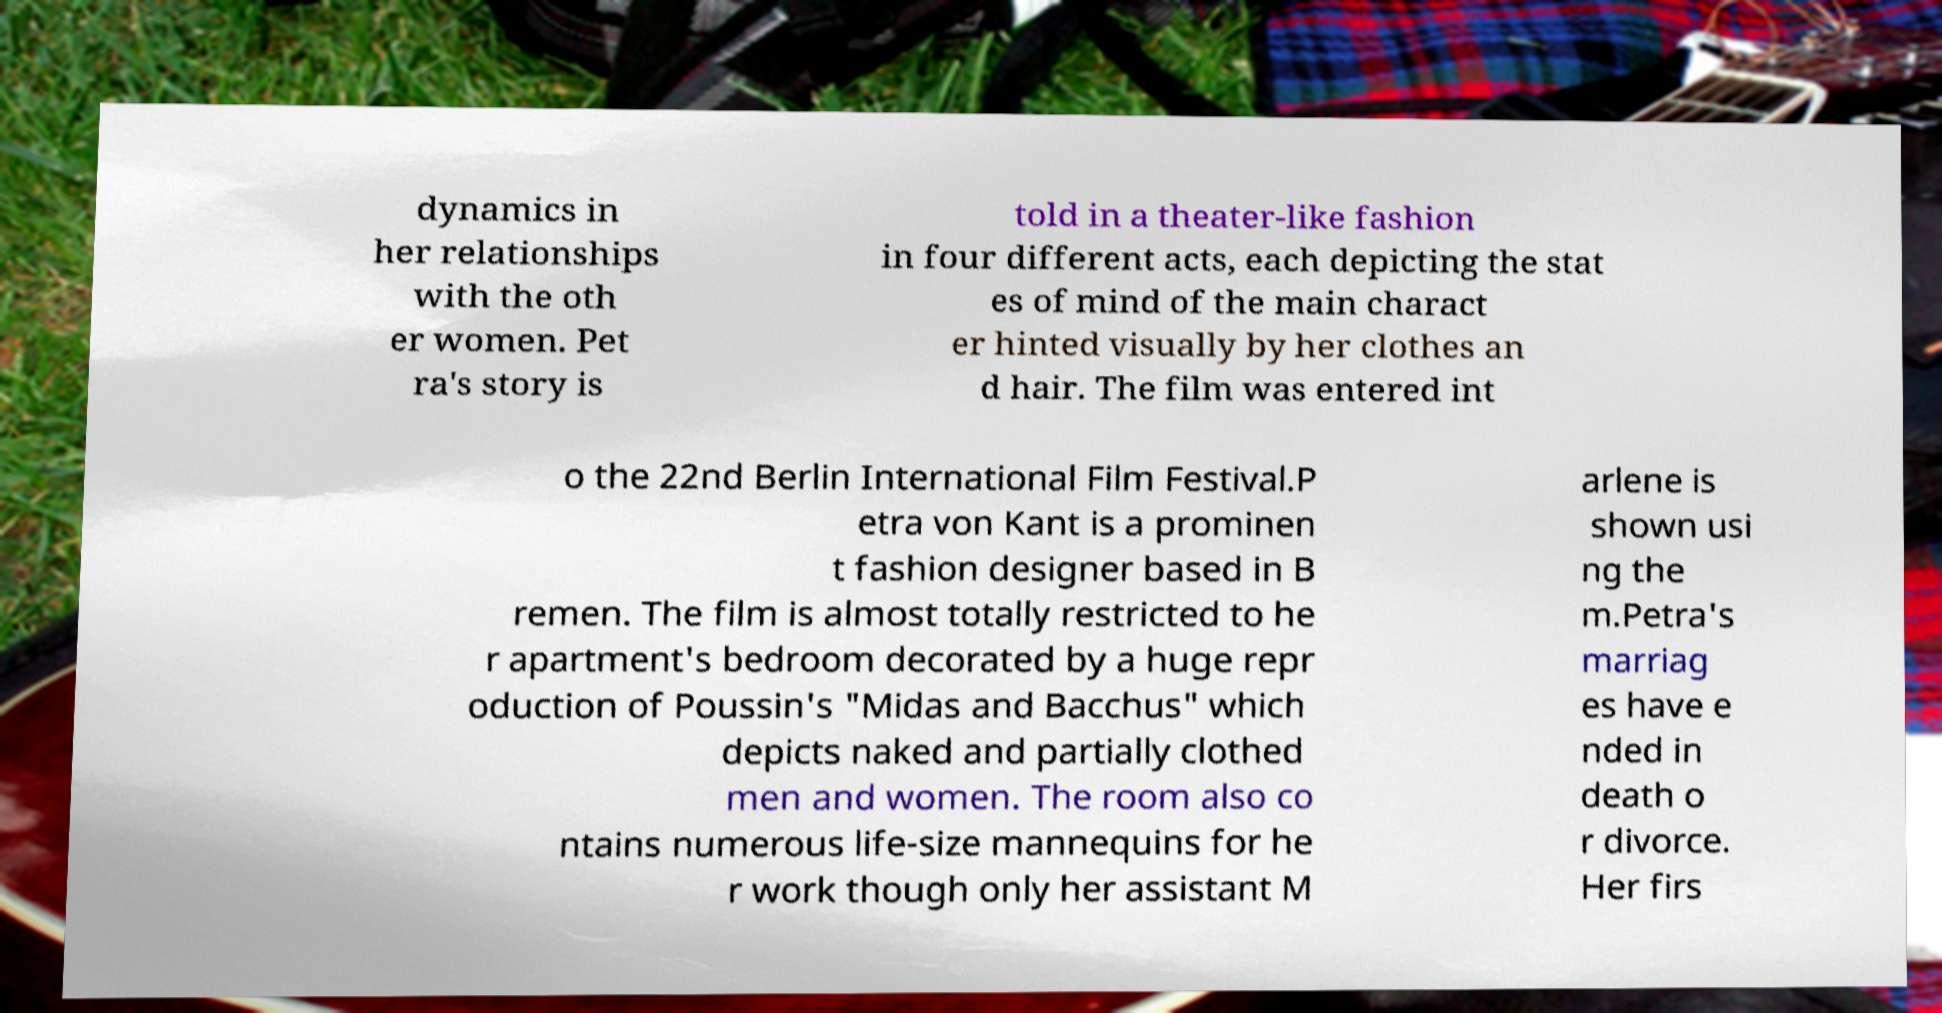Could you assist in decoding the text presented in this image and type it out clearly? dynamics in her relationships with the oth er women. Pet ra's story is told in a theater-like fashion in four different acts, each depicting the stat es of mind of the main charact er hinted visually by her clothes an d hair. The film was entered int o the 22nd Berlin International Film Festival.P etra von Kant is a prominen t fashion designer based in B remen. The film is almost totally restricted to he r apartment's bedroom decorated by a huge repr oduction of Poussin's "Midas and Bacchus" which depicts naked and partially clothed men and women. The room also co ntains numerous life-size mannequins for he r work though only her assistant M arlene is shown usi ng the m.Petra's marriag es have e nded in death o r divorce. Her firs 